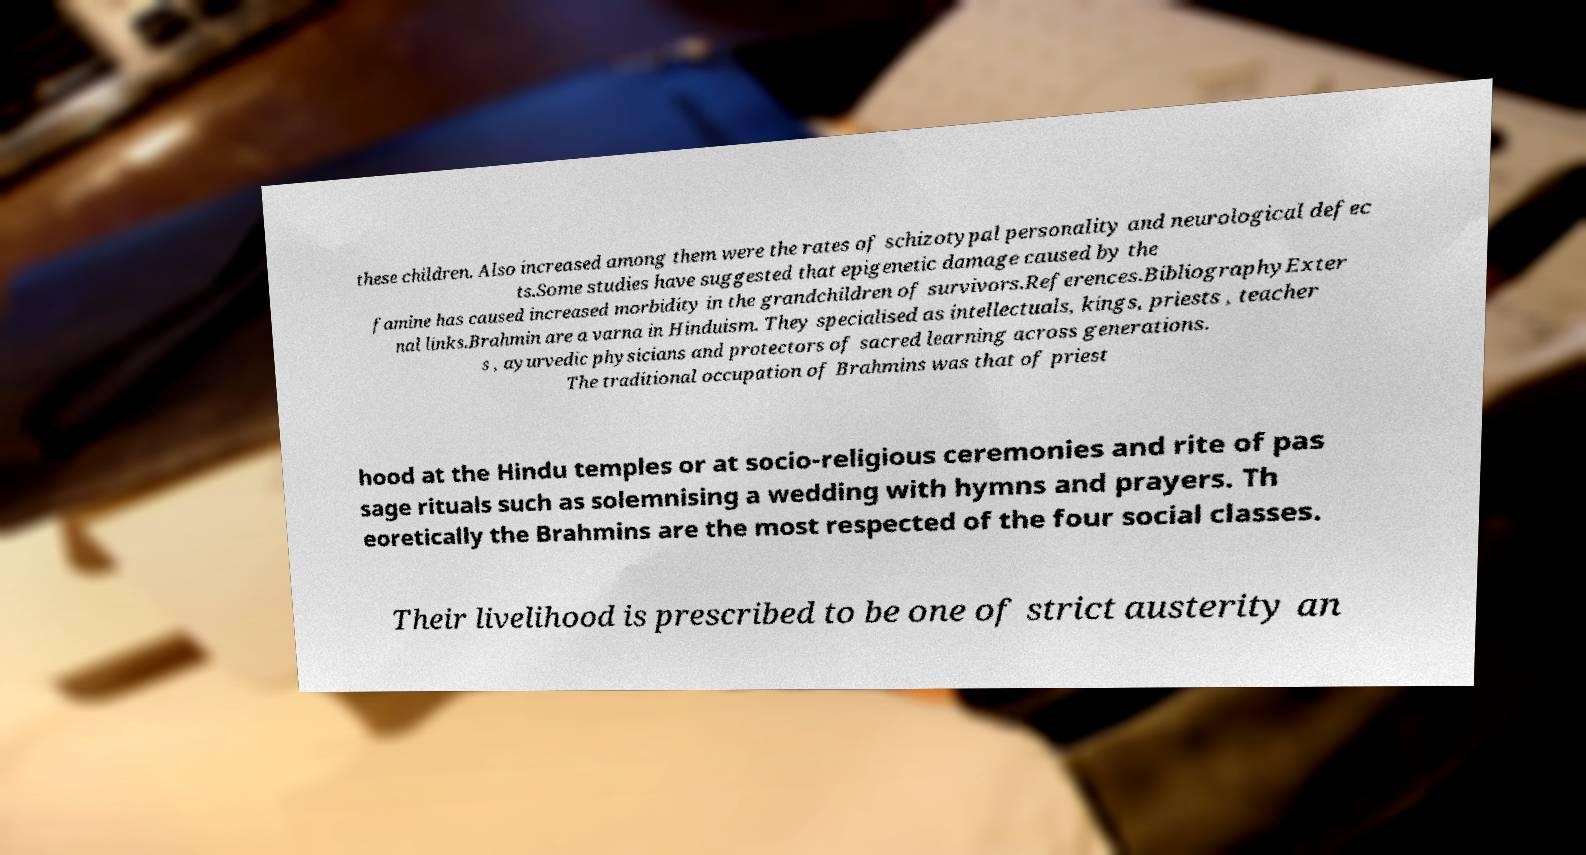Please identify and transcribe the text found in this image. these children. Also increased among them were the rates of schizotypal personality and neurological defec ts.Some studies have suggested that epigenetic damage caused by the famine has caused increased morbidity in the grandchildren of survivors.References.BibliographyExter nal links.Brahmin are a varna in Hinduism. They specialised as intellectuals, kings, priests , teacher s , ayurvedic physicians and protectors of sacred learning across generations. The traditional occupation of Brahmins was that of priest hood at the Hindu temples or at socio-religious ceremonies and rite of pas sage rituals such as solemnising a wedding with hymns and prayers. Th eoretically the Brahmins are the most respected of the four social classes. Their livelihood is prescribed to be one of strict austerity an 